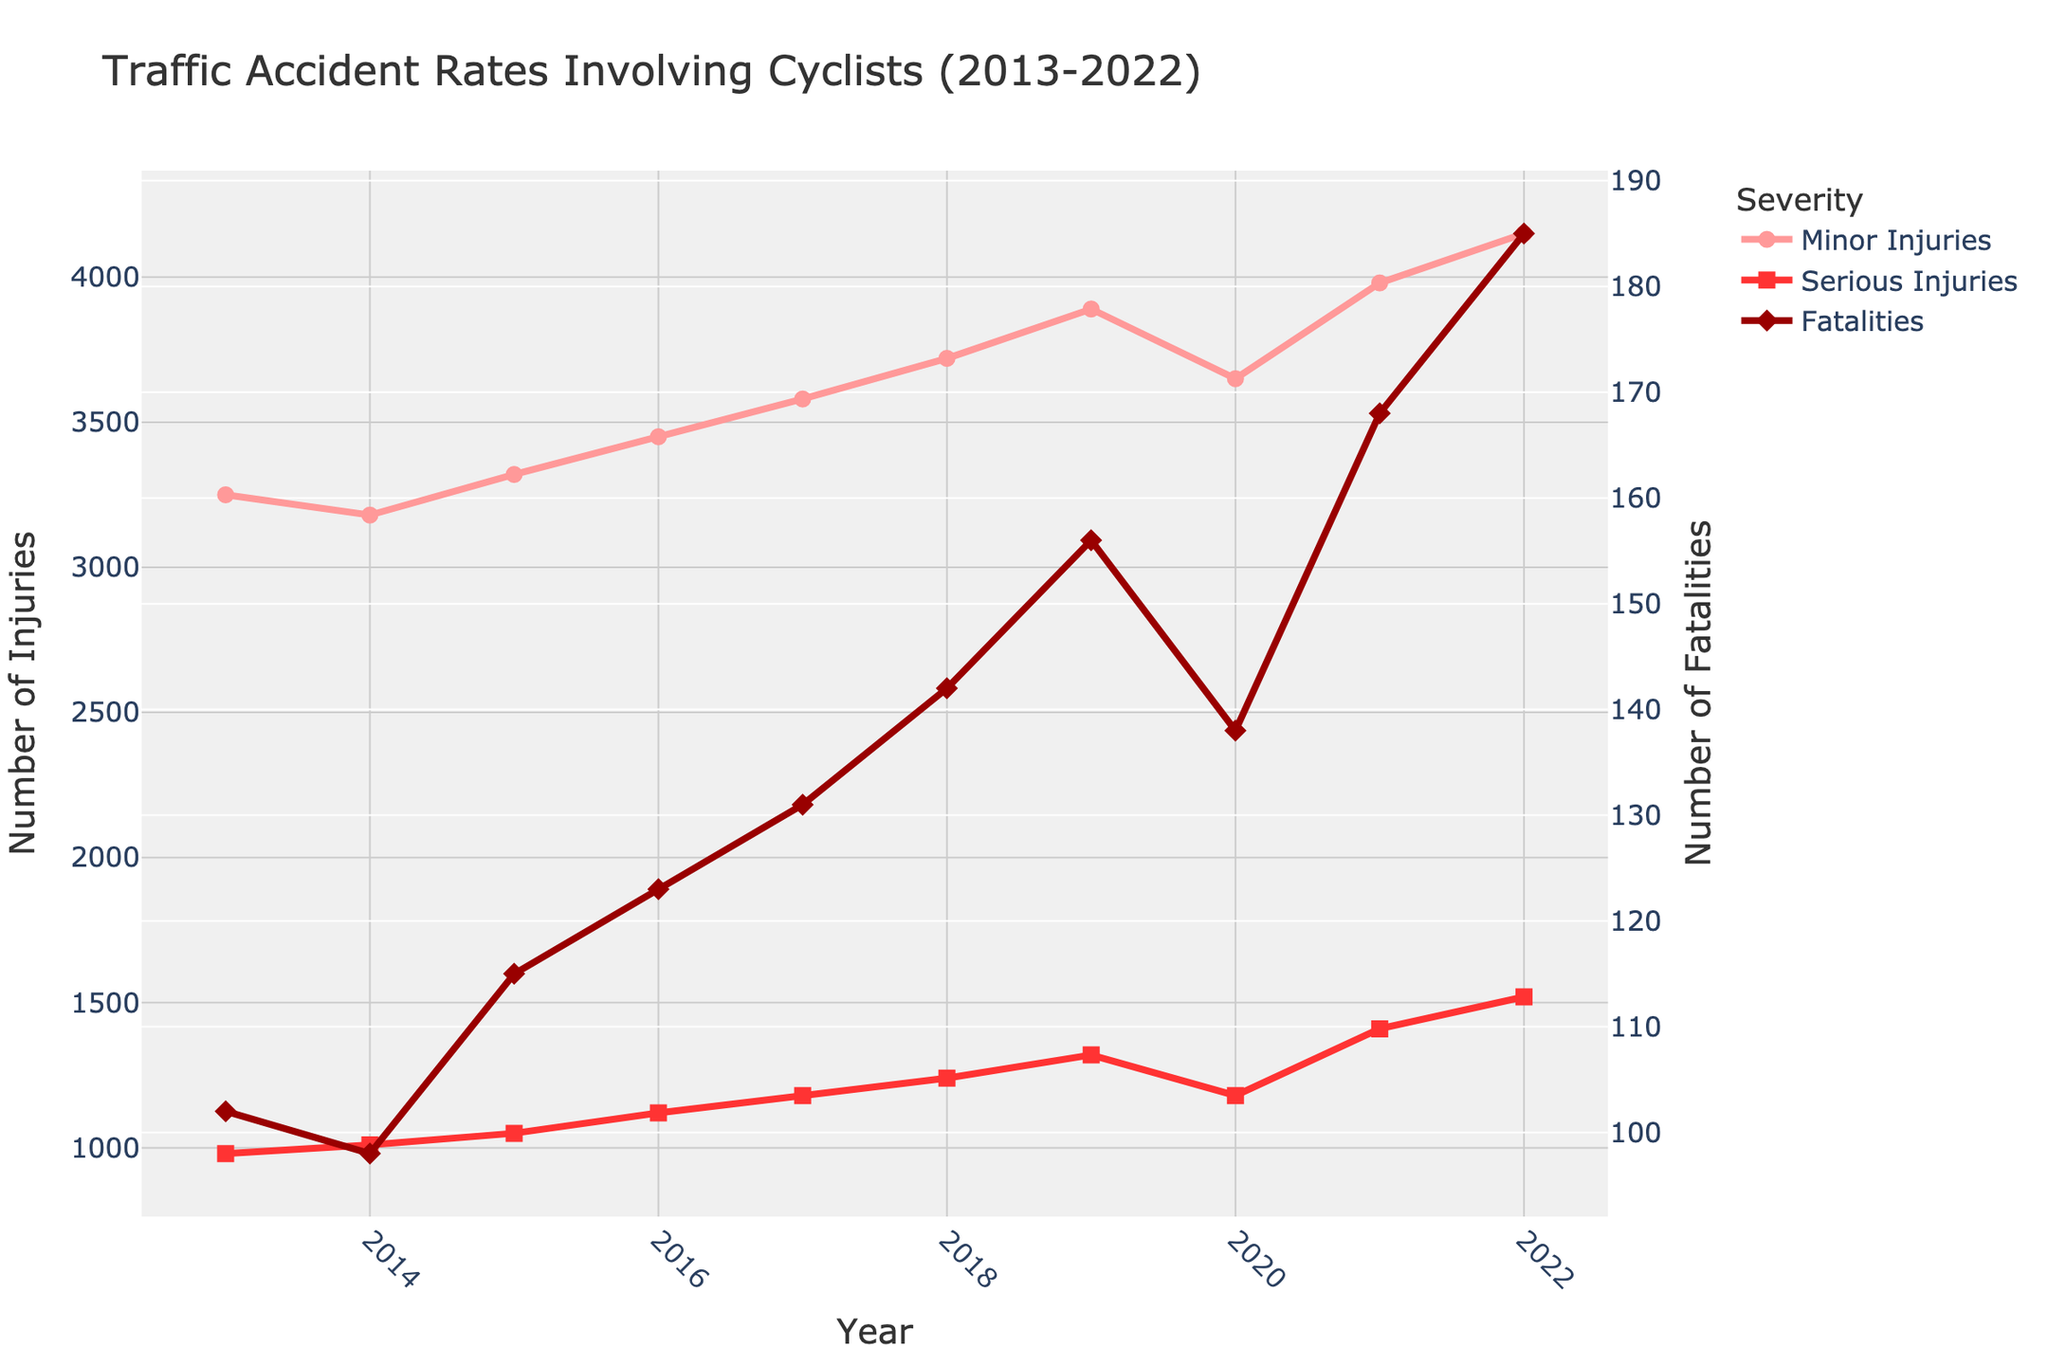What year had the highest number of serious injuries? By looking at the year with the highest value on the "Serious Injuries" line, you can tell that 2022 had the highest number.
Answer: 2022 In which year did the fatalities exceed 150 for the first time? Checking the "Fatalities" line, it first crosses 150 in the year 2019.
Answer: 2019 How much did the number of minor injuries increase from 2016 to 2022? Minor injuries in 2016 were 3450, and in 2022 they were 4150. The increase is 4150 - 3450.
Answer: 700 Which had a greater increase from 2013 to 2022, minor injuries or serious injuries? Minor injuries went from 3250 to 4150, an increase of 900. Serious injuries went from 980 to 1520, an increase of 540. Therefore, minor injuries had a greater increase.
Answer: Minor injuries What is the combined number of serious injuries and fatalities in 2018? Serious injuries in 2018 were 1240 and fatalities were 142. The combined number is 1240 + 142.
Answer: 1382 Between which consecutive years did the number of serious injuries increase the most? By checking the differences year by year for serious injuries, the increase is highest between 2021 (1410) and 2022 (1520), which is 110.
Answer: 2021 to 2022 Is there any year where both serious injuries and fatalities decreased compared to the previous year? Serious injuries and fatalities both decreased in 2020 compared to 2019 (Serious injuries: 1320 to 1180, Fatalities: 156 to 138).
Answer: Yes, 2020 Are the fatalities showing an overall increasing or decreasing trend from 2013 to 2022? Observing the "Fatalities" line, it shows an increasing trend from 102 in 2013 to 185 in 2022.
Answer: Increasing What is the average number of fatalities over the decade? To find the average, sum the fatalities from 2013 to 2022 and divide by the number of years (10). The total is 1158, so the average is 1158/10.
Answer: 115.8 Which category and year had the lowest value in the entire dataset? The lowest value in the dataset is for fatalities in 2014, which is 98.
Answer: Fatalities in 2014 